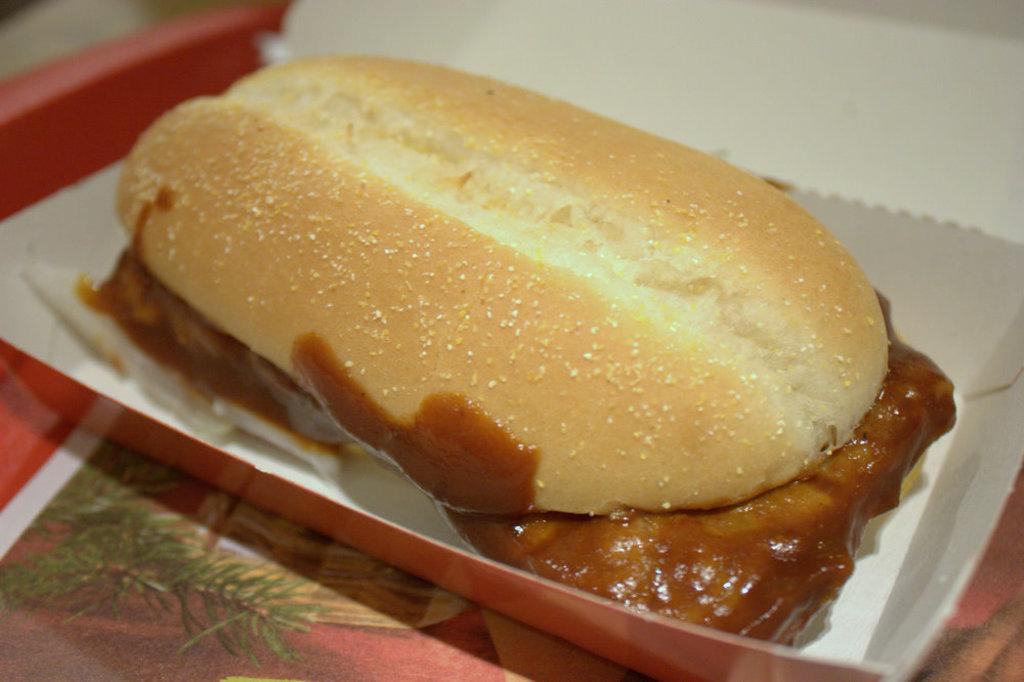What is the main subject of the image? There is a food item in the image. Where is the food item located? The food item is on a surface. What type of lead can be seen in the image? There is no lead present in the image. The image only features a food item on a surface. 